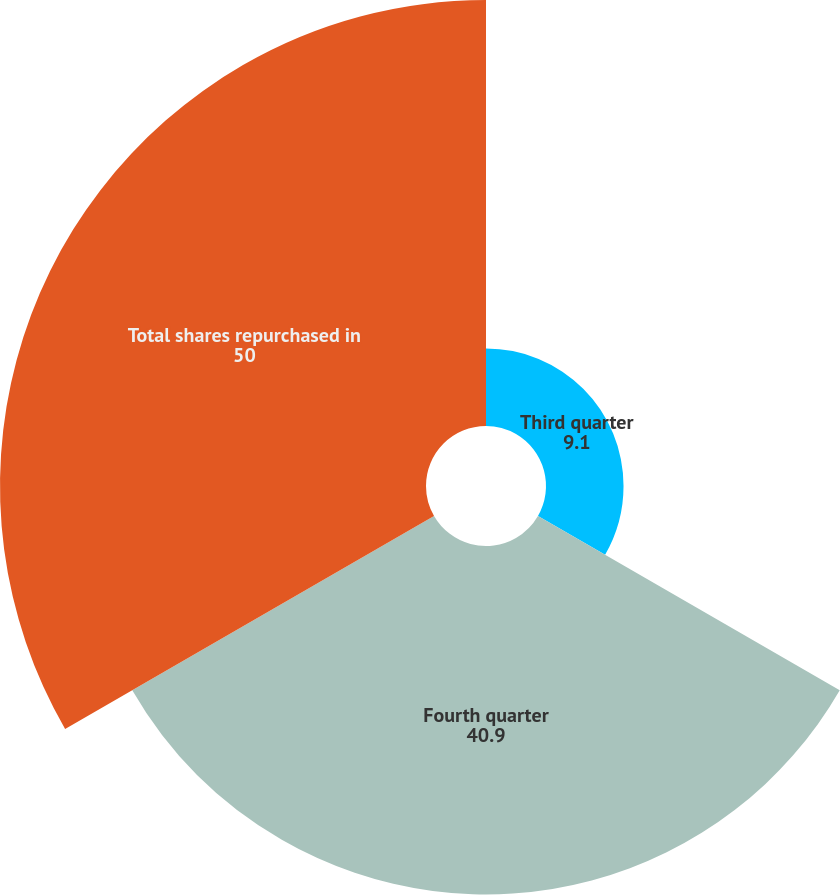<chart> <loc_0><loc_0><loc_500><loc_500><pie_chart><fcel>Third quarter<fcel>Fourth quarter<fcel>Total shares repurchased in<nl><fcel>9.1%<fcel>40.9%<fcel>50.0%<nl></chart> 